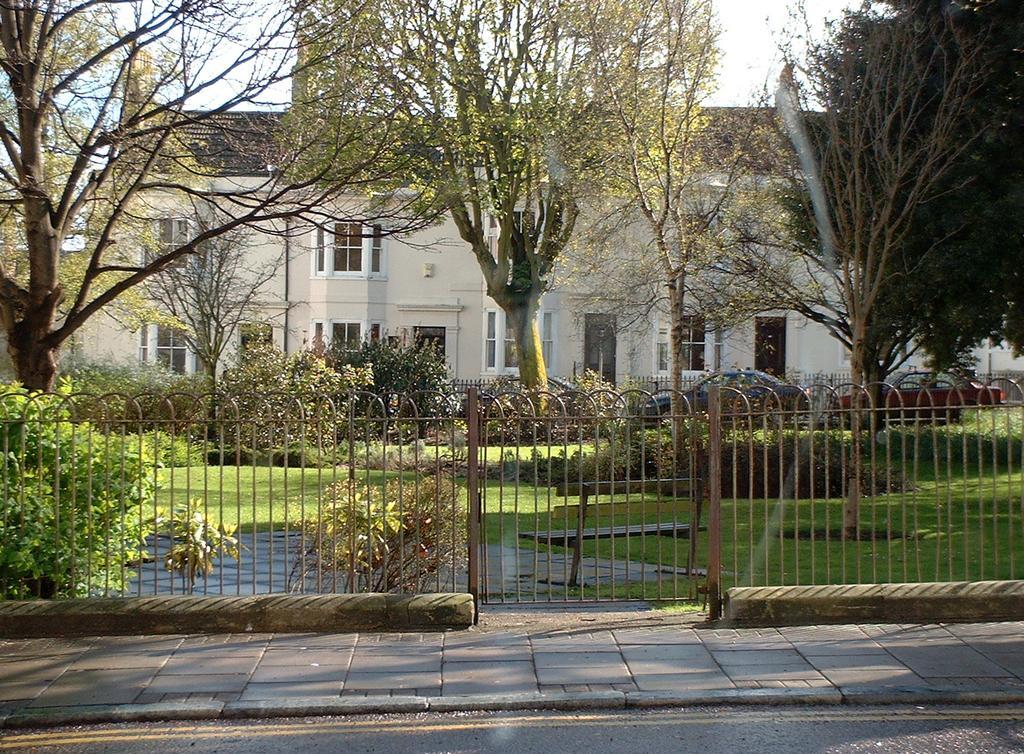Please provide a concise description of this image. In front of the image there is a road. There is a metal fence. There are plants, trees, buildings, cars and a bench. At the bottom of the image there is grass on the surface. At the top of the image there is sky. 